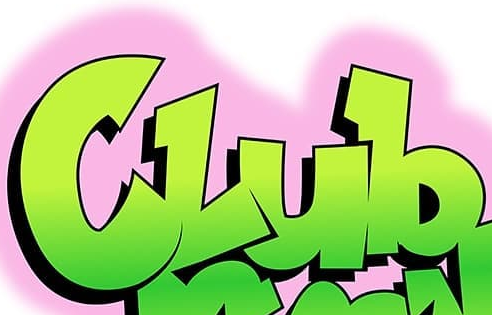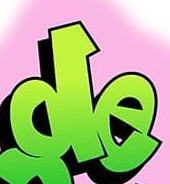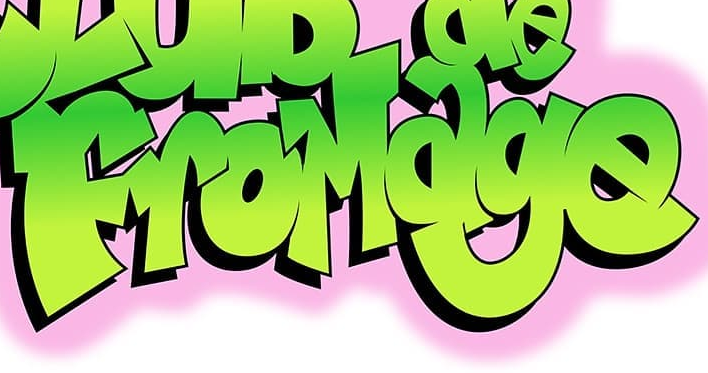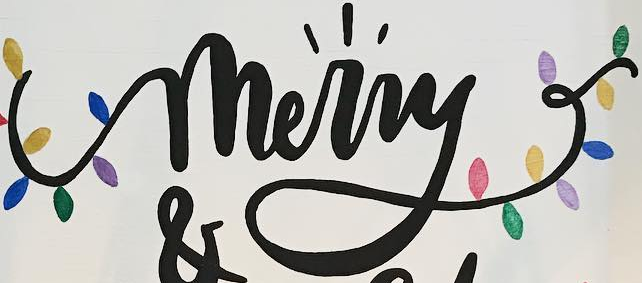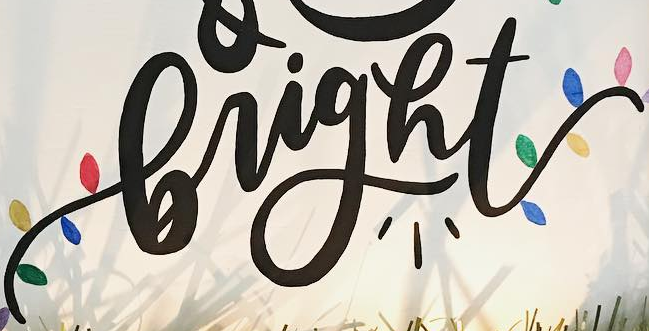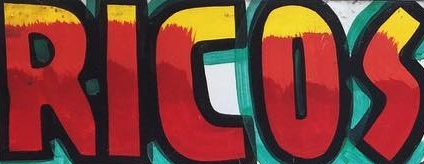What words are shown in these images in order, separated by a semicolon? Club; de; FroMage; merry; bright; RICOS 